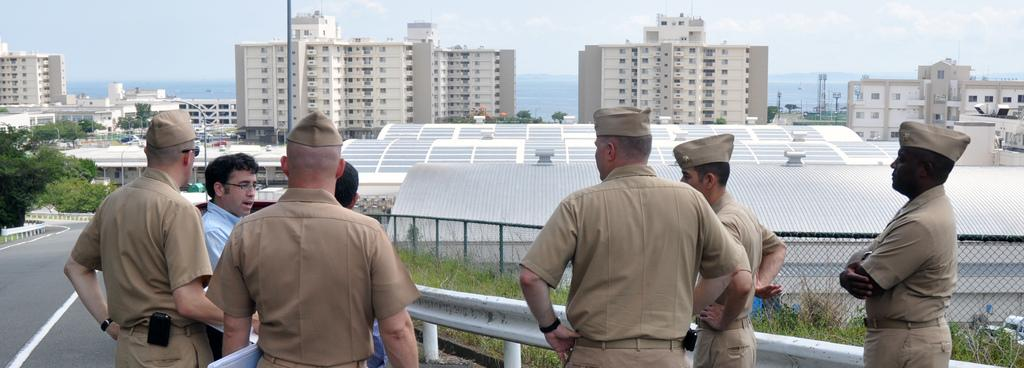What type of people can be seen in the image? There are policemen in the image. What can be seen on the side of the road in the image? There are trees on the side of the road in the image. What is visible in the background of the image? There is fencing, buildings, and the sky visible in the background of the image. What type of cat can be seen holding a bucket in the image? There is no cat or bucket present in the image. How does the presence of the policemen affect the nerves of the people in the image? The image does not show the reaction of the people to the presence of the policemen, so it cannot be determined how their nerves might be affected. 